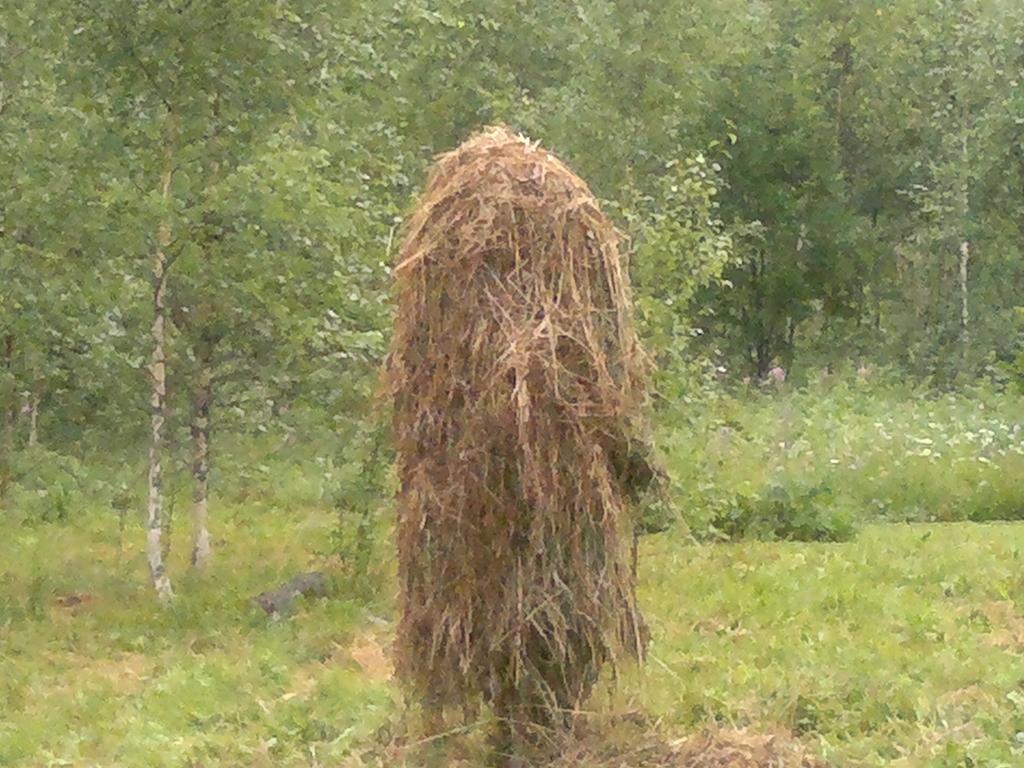In one or two sentences, can you explain what this image depicts? In the center of the image there is dry grass. In the background of the image there are trees. At the bottom of the image there is grass. 